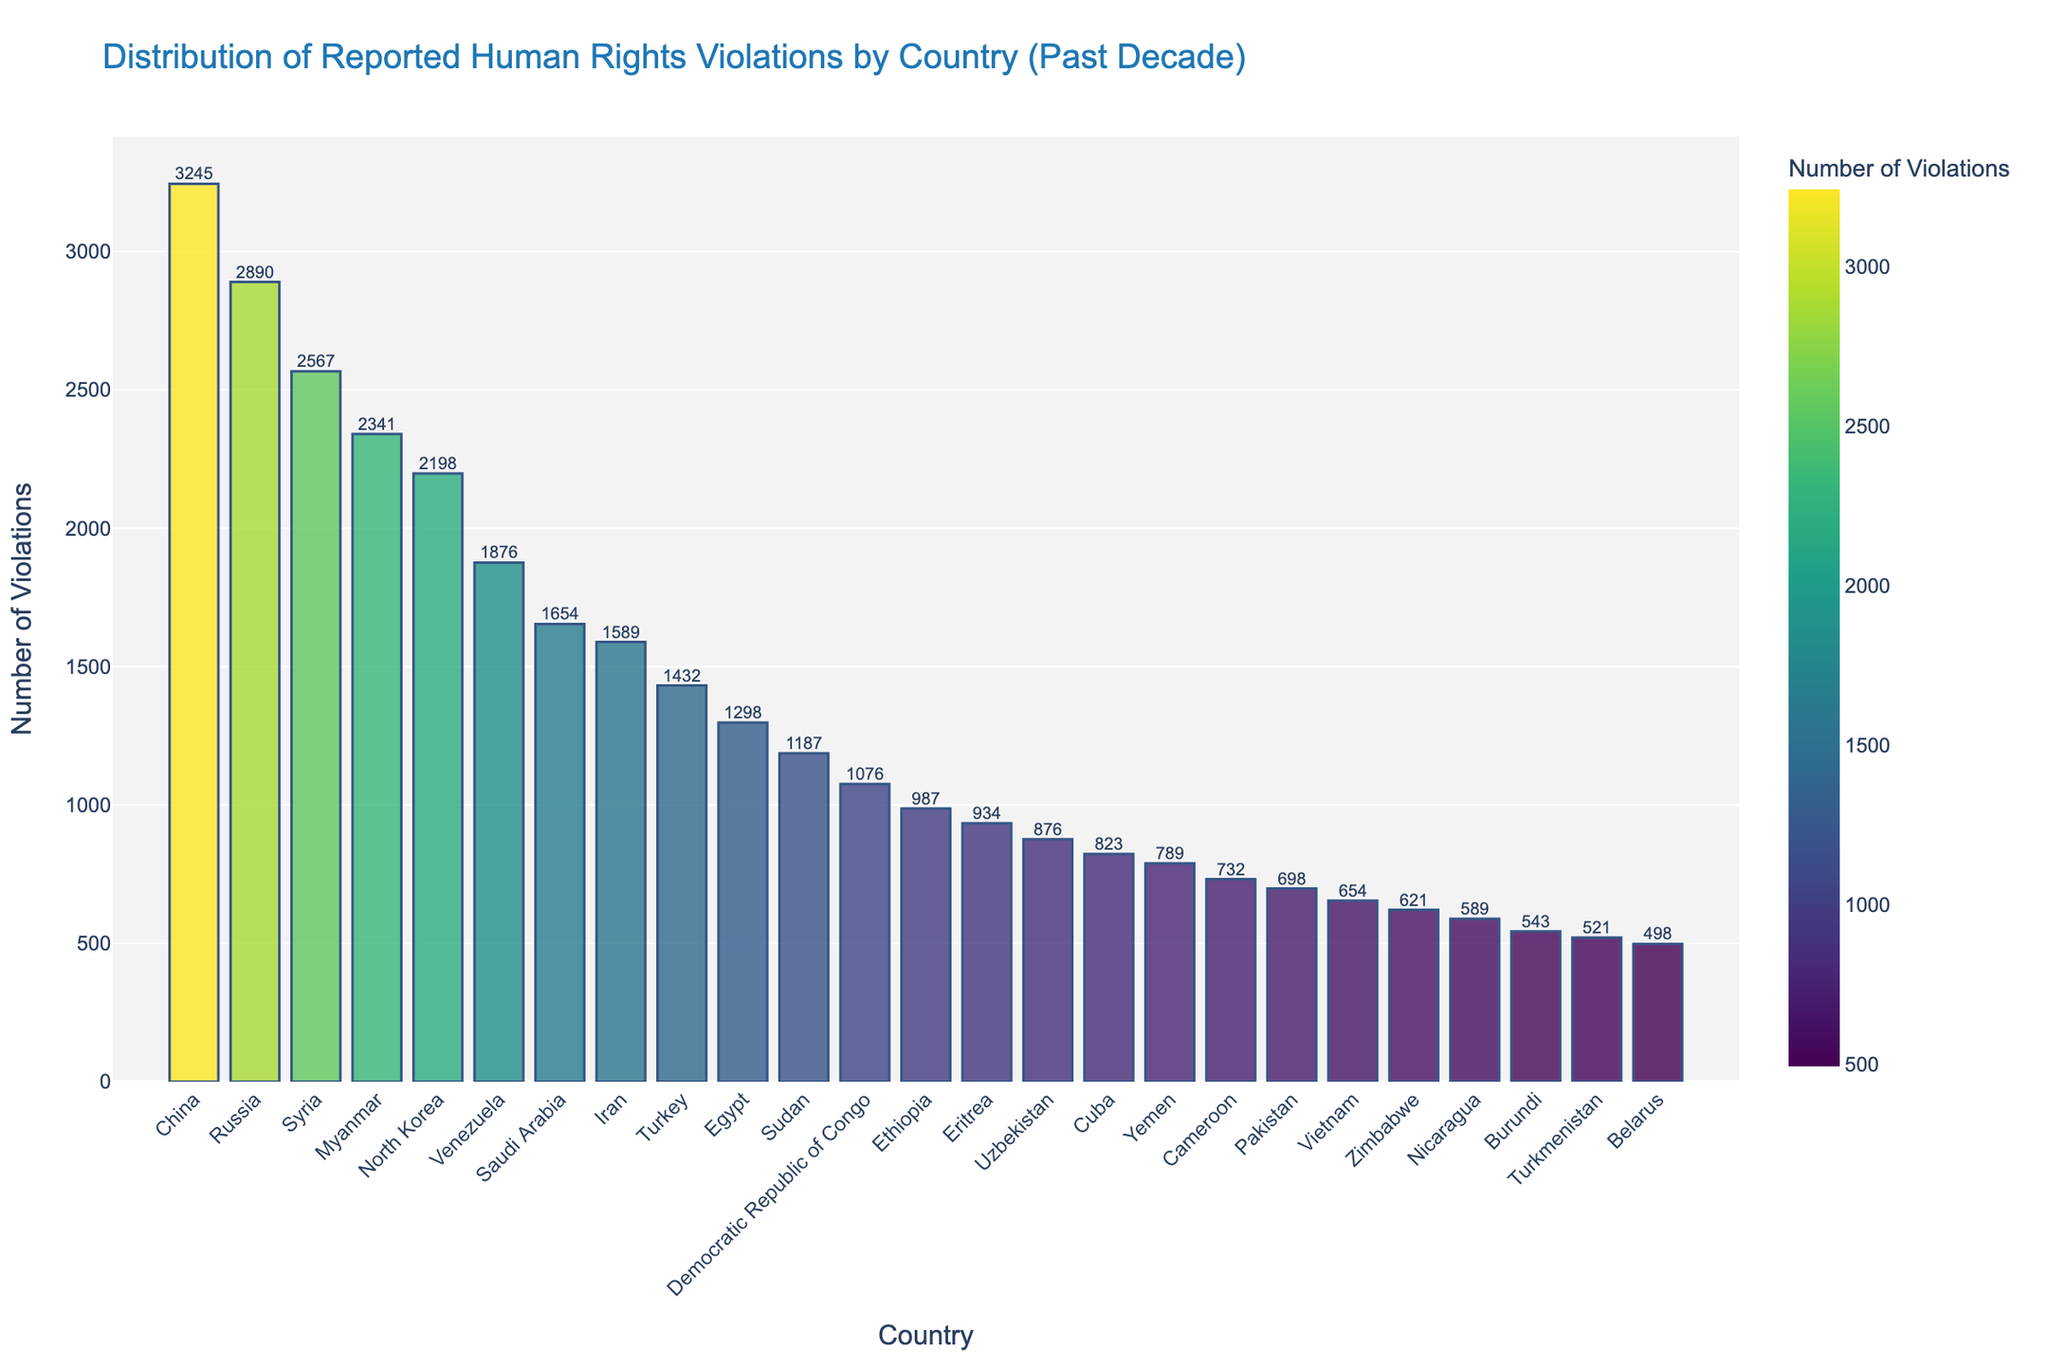Which country has the highest number of reported human rights violations? The highest bar on the chart is for China, indicating that it has the most reported human rights violations.
Answer: China Which countries have fewer than 1000 reported human rights violations? The bars for Ethiopia, Eritrea, Uzbekistan, Cuba, Yemen, Cameroon, Pakistan, Vietnam, Zimbabwe, Nicaragua, Burundi, Turkmenistan, and Belarus are all below the 1000 mark on the y-axis.
Answer: Ethiopia, Eritrea, Uzbekistan, Cuba, Yemen, Cameroon, Pakistan, Vietnam, Zimbabwe, Nicaragua, Burundi, Turkmenistan, Belarus How many more reported human rights violations are there in China compared to Russia? China's bar is at 3245 violations and Russia's bar is at 2890 violations. The difference is 3245 - 2890.
Answer: 355 Which country is ranked third in terms of reported human rights violations? Looking at the sorted bars from highest to lowest, Syria is the third bar.
Answer: Syria Are there any countries with exactly similar numbers of reported human rights violations? No two bars in the chart are at the same height, indicating that each country has a unique number of reported violations.
Answer: No What is the combined number of reported human rights violations in North Korea and Venezuela? Adding the values for North Korea (2198) and Venezuela (1876) gives 2198 + 1876.
Answer: 4074 Which country has the fifth highest number of reported human rights violations? By examining the bars sorted in descending order, North Korea is the fifth bar.
Answer: North Korea Is Iran ranked higher or lower than Saudi Arabia in terms of reported human rights violations? Physically comparing the heights of the bars for Saudi Arabia (1654) and Iran (1589), Saudi Arabia's bar is taller.
Answer: Lower What is the total number of reported human rights violations for the bottom five countries on the list? The countries in the last five positions are Nicaragua (589), Burundi (543), Turkmenistan (521), Belarus (498). Summing them, 589 + 543 + 521 + 498.
Answer: 2151 How many countries have reported human rights violations within the range of 500 to 1000? By counting the bars that fall between the 500 and 1000 marks on the y-axis, the countries are Ethiopia (987), Eritrea (934), Uzbekistan (876), Cuba (823), Yemen (789), Cameroon (732), Pakistan (698), Vietnam (654), Zimbabwe (621), Nicaragua (589), Burundi (543), Turkmenistan (521). There are 12 countries in total.
Answer: 12 